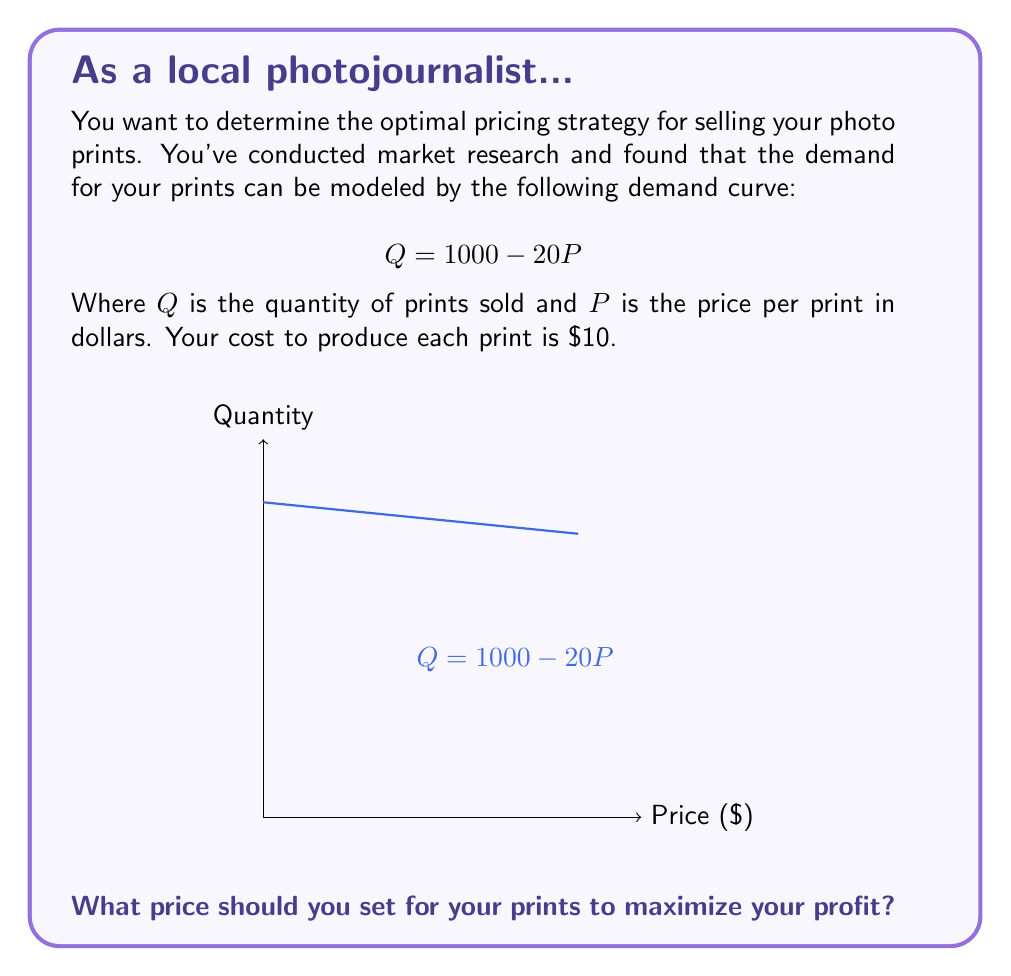Can you solve this math problem? To solve this problem, we'll follow these steps:

1) First, let's express the profit function. Profit is revenue minus cost:
   $$\text{Profit} = \text{Revenue} - \text{Cost}$$

2) Revenue is price times quantity:
   $$\text{Revenue} = P \cdot Q = P(1000 - 20P) = 1000P - 20P^2$$

3) Cost is $10 per unit, so total cost is:
   $$\text{Cost} = 10Q = 10(1000 - 20P) = 10000 - 200P$$

4) Now we can express the profit function:
   $$\text{Profit} = (1000P - 20P^2) - (10000 - 200P)$$
   $$\text{Profit} = -20P^2 + 1200P - 10000$$

5) To find the maximum profit, we need to find the vertex of this quadratic function. We can do this by finding where the derivative equals zero:
   $$\frac{d(\text{Profit})}{dP} = -40P + 1200 = 0$$

6) Solving this equation:
   $$-40P + 1200 = 0$$
   $$-40P = -1200$$
   $$P = 30$$

7) To confirm this is a maximum (not a minimum), we can check that the second derivative is negative:
   $$\frac{d^2(\text{Profit})}{dP^2} = -40 < 0$$

Therefore, the profit is maximized when the price is $30 per print.
Answer: $30 per print 